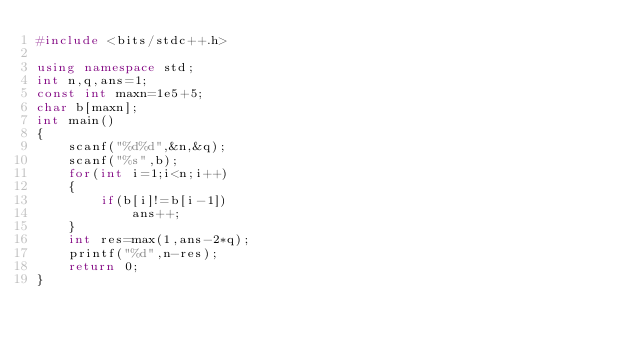<code> <loc_0><loc_0><loc_500><loc_500><_C++_>#include <bits/stdc++.h>

using namespace std;
int n,q,ans=1;
const int maxn=1e5+5;
char b[maxn];
int main()
{
    scanf("%d%d",&n,&q);
    scanf("%s",b);
    for(int i=1;i<n;i++)
    {
        if(b[i]!=b[i-1])
            ans++;
    }
    int res=max(1,ans-2*q);
    printf("%d",n-res);
    return 0;
}
</code> 